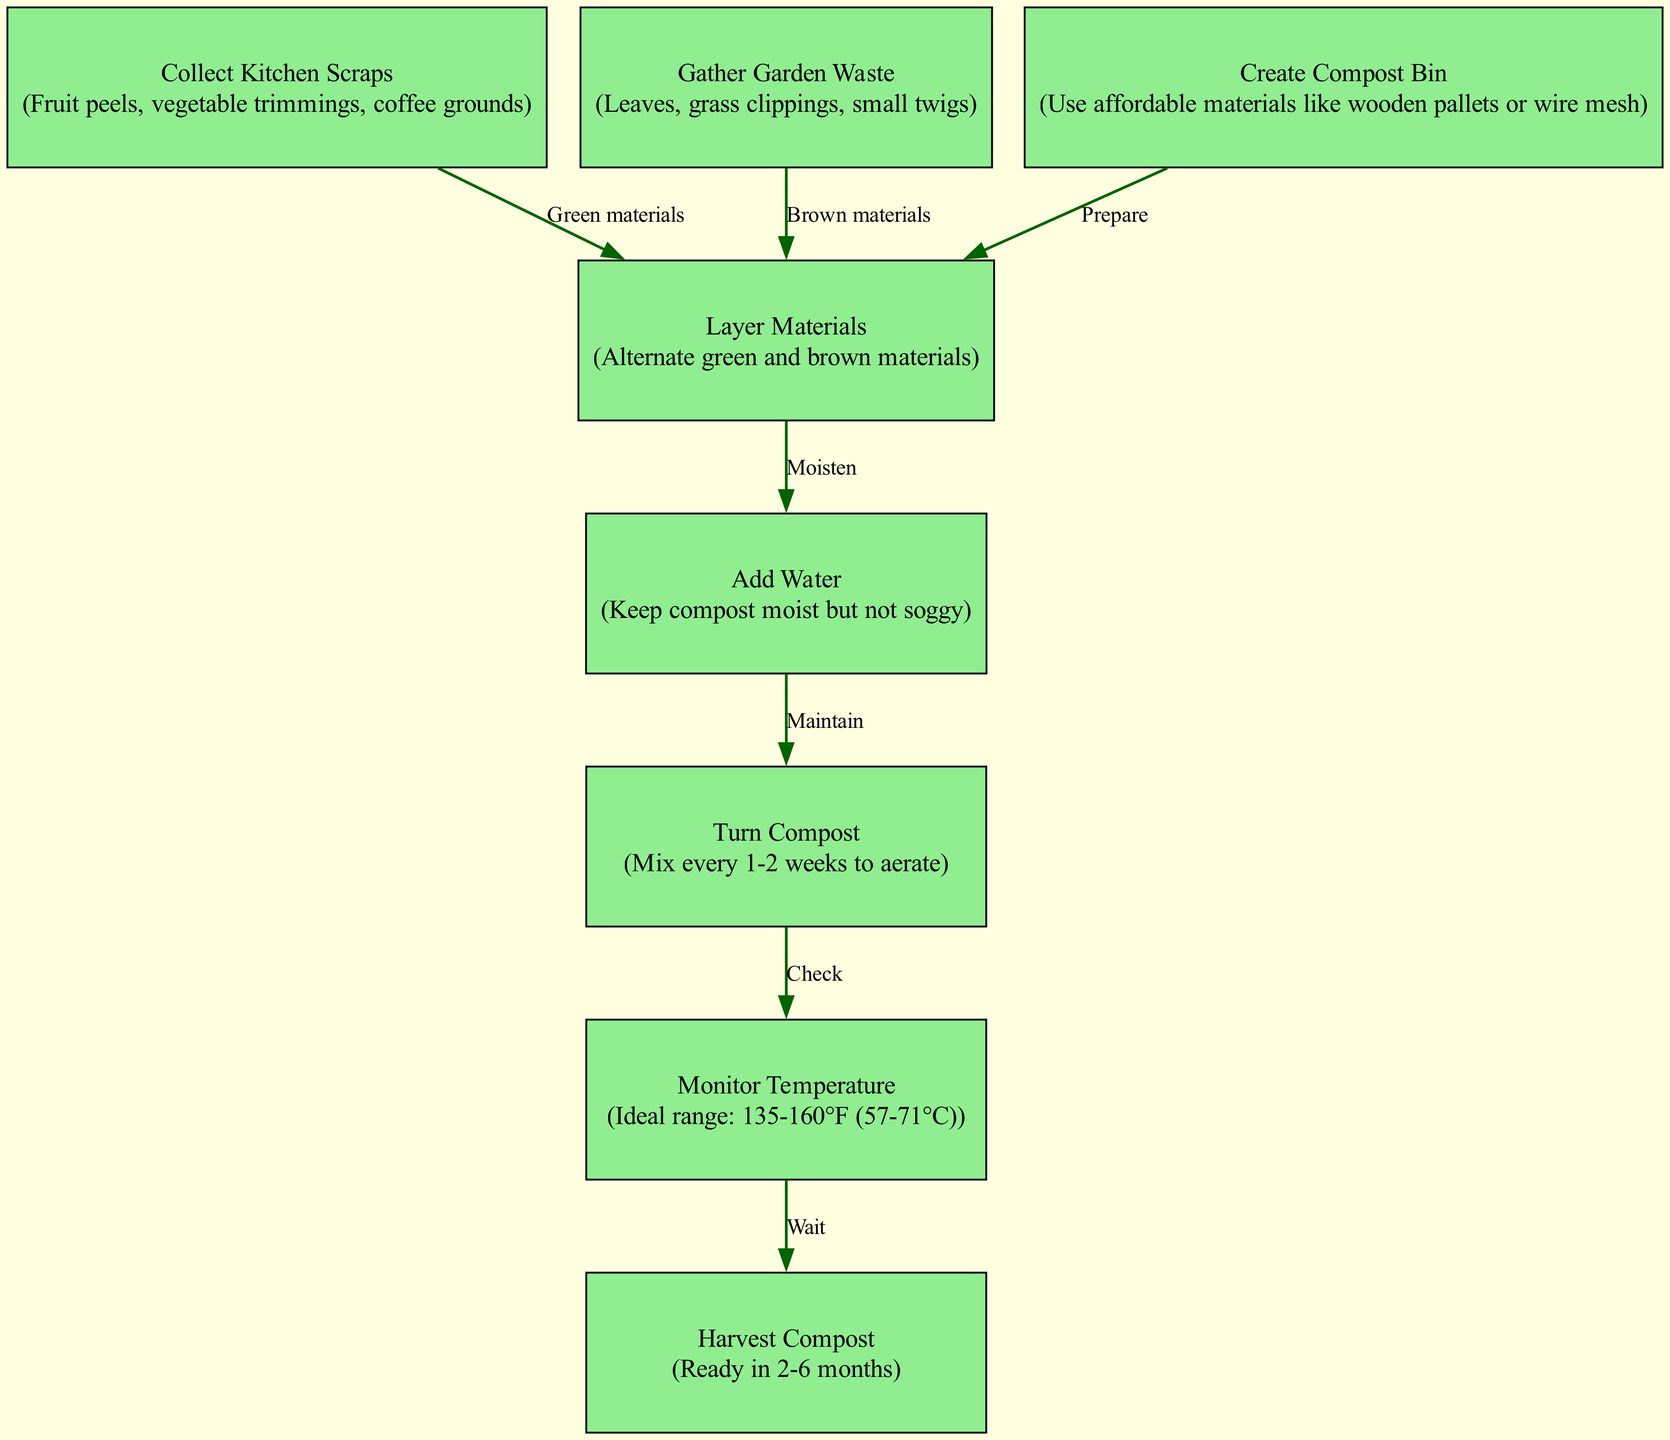What is the first step in the composting process? The diagram shows that the first step is to "Collect Kitchen Scraps". This is indicated in node 1, which is the starting point of the composting process.
Answer: Collect Kitchen Scraps How many nodes are shown in the diagram? By counting all the nodes present in the diagram, there are 8 distinct steps or nodes related to the composting process.
Answer: 8 What materials are used for gathering garden waste? Node 2 explicitly lists the materials used for gathering garden waste as "Leaves, grass clippings, small twigs". This provides the specific items considered garden waste.
Answer: Leaves, grass clippings, small twigs What do you need to do after creating the compost bin? The diagram indicates that after creating the compost bin (node 3), the next step is to "Layer Materials" (node 4). This shows a clear progression from preparing the bin to layering different materials.
Answer: Layer Materials What should be added to maintain compost moisture? Referring to node 5, the diagram states that "Add Water" is necessary to keep the compost moist but not soggy, indicating the moisture requirement for successful composting.
Answer: Add Water What is the ideal temperature range for monitoring compost? According to node 7 in the diagram, the ideal temperature range for composting is provided as "135-160°F (57-71°C)". This detail specifies the condition needed for the composting process.
Answer: 135-160°F (57-71°C) What is the final step of composting after monitoring temperature? The diagram shows that the final step after checking the temperature (node 7) is to "Harvest Compost" (node 8), indicating that harvesting is the concluding action of the composting process.
Answer: Harvest Compost What is the relationship between adding water and turning compost? The diagram illustrates that after adding water (node 5), the next action required is to "Turn Compost" (node 6). This indicates an ongoing maintenance activity that is necessary following moisture addition.
Answer: Turn Compost 